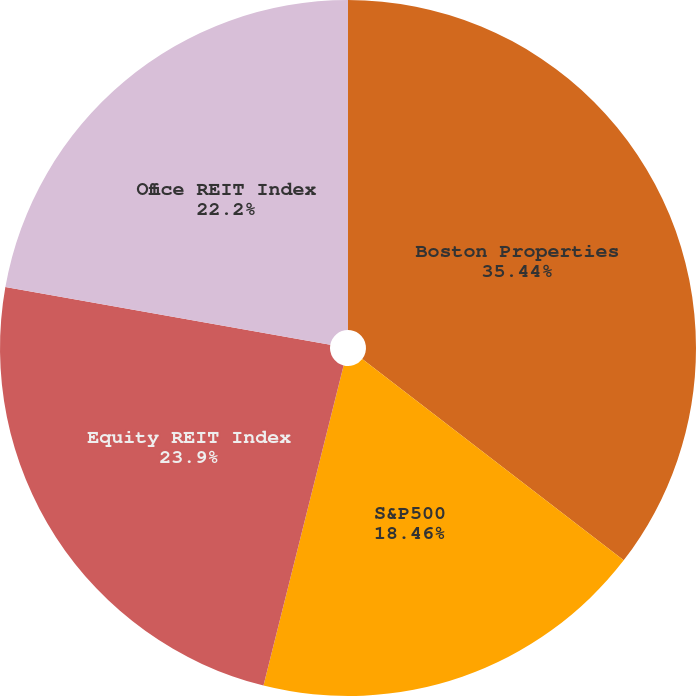<chart> <loc_0><loc_0><loc_500><loc_500><pie_chart><fcel>Boston Properties<fcel>S&P500<fcel>Equity REIT Index<fcel>Office REIT Index<nl><fcel>35.45%<fcel>18.46%<fcel>23.9%<fcel>22.2%<nl></chart> 